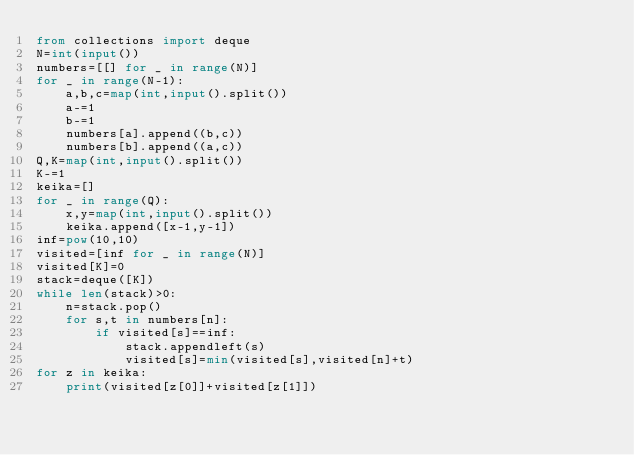<code> <loc_0><loc_0><loc_500><loc_500><_Python_>from collections import deque
N=int(input())
numbers=[[] for _ in range(N)]
for _ in range(N-1):
    a,b,c=map(int,input().split())
    a-=1
    b-=1
    numbers[a].append((b,c))
    numbers[b].append((a,c))
Q,K=map(int,input().split())
K-=1
keika=[]
for _ in range(Q):
    x,y=map(int,input().split())
    keika.append([x-1,y-1])
inf=pow(10,10)
visited=[inf for _ in range(N)]
visited[K]=0
stack=deque([K])
while len(stack)>0:
    n=stack.pop()
    for s,t in numbers[n]:
        if visited[s]==inf:
            stack.appendleft(s)
            visited[s]=min(visited[s],visited[n]+t)
for z in keika:
    print(visited[z[0]]+visited[z[1]])
</code> 